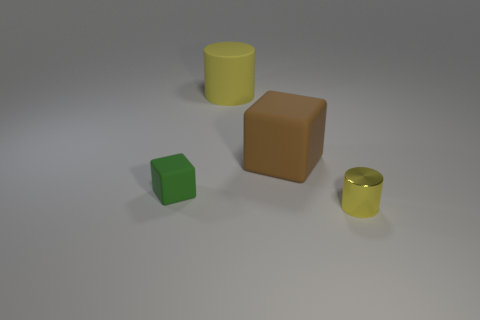Is the number of yellow shiny objects greater than the number of large matte objects?
Your answer should be very brief. No. What is the size of the metallic cylinder that is the same color as the large matte cylinder?
Your response must be concise. Small. There is a yellow object that is in front of the tiny thing behind the tiny metal object; what is its shape?
Keep it short and to the point. Cylinder. Is there a big brown cube that is left of the big yellow thing that is behind the yellow thing that is in front of the large cube?
Your answer should be compact. No. The rubber object that is the same size as the brown rubber cube is what color?
Your answer should be compact. Yellow. There is a object that is both right of the big yellow rubber object and behind the small rubber cube; what shape is it?
Keep it short and to the point. Cube. There is a yellow object that is to the left of the large thing in front of the large yellow matte thing; what size is it?
Provide a short and direct response. Large. How many other shiny cylinders are the same color as the tiny shiny cylinder?
Give a very brief answer. 0. What number of other things are the same size as the brown matte cube?
Provide a succinct answer. 1. There is a object that is both on the right side of the large yellow rubber cylinder and on the left side of the small yellow thing; what is its size?
Provide a succinct answer. Large. 